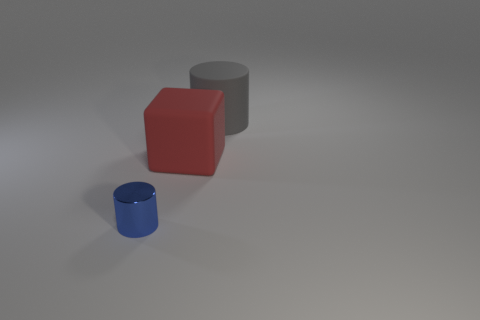Is there any other thing that has the same material as the small blue cylinder?
Your response must be concise. No. What number of other things are there of the same size as the gray object?
Keep it short and to the point. 1. Is there a matte cylinder behind the cylinder behind the big matte thing left of the gray matte thing?
Provide a short and direct response. No. Does the cylinder on the right side of the small blue thing have the same material as the large red thing?
Your answer should be compact. Yes. What color is the other matte thing that is the same shape as the tiny blue object?
Offer a very short reply. Gray. Is there any other thing that is the same shape as the blue metal thing?
Offer a very short reply. Yes. Is the number of matte blocks that are on the right side of the red thing the same as the number of green matte cylinders?
Make the answer very short. Yes. There is a small blue shiny cylinder; are there any red rubber things in front of it?
Offer a very short reply. No. How big is the block on the left side of the cylinder that is behind the cylinder on the left side of the big gray thing?
Offer a very short reply. Large. Do the thing behind the cube and the thing that is on the left side of the large block have the same shape?
Offer a terse response. Yes. 